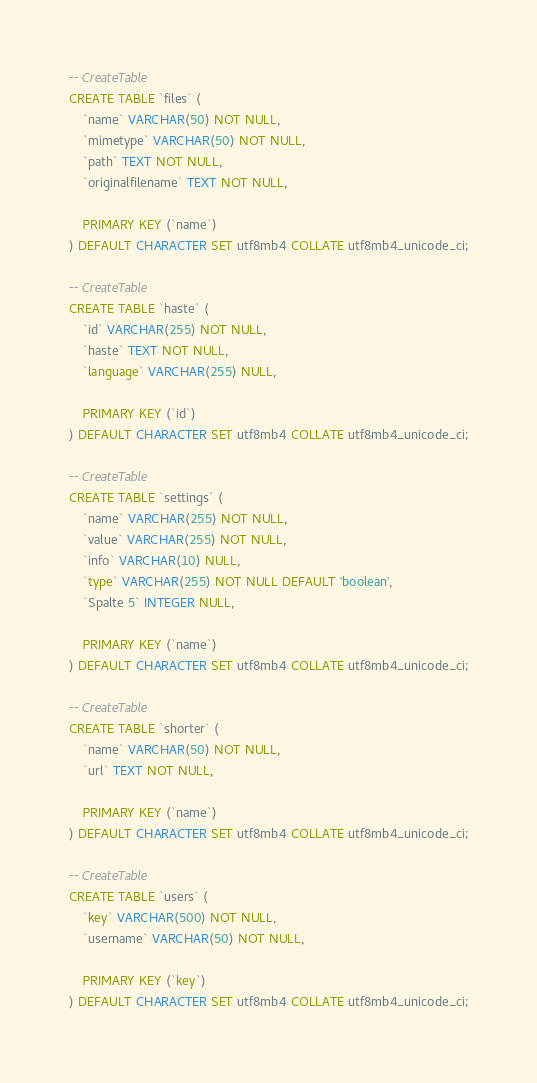<code> <loc_0><loc_0><loc_500><loc_500><_SQL_>-- CreateTable
CREATE TABLE `files` (
    `name` VARCHAR(50) NOT NULL,
    `mimetype` VARCHAR(50) NOT NULL,
    `path` TEXT NOT NULL,
    `originalfilename` TEXT NOT NULL,

    PRIMARY KEY (`name`)
) DEFAULT CHARACTER SET utf8mb4 COLLATE utf8mb4_unicode_ci;

-- CreateTable
CREATE TABLE `haste` (
    `id` VARCHAR(255) NOT NULL,
    `haste` TEXT NOT NULL,
    `language` VARCHAR(255) NULL,

    PRIMARY KEY (`id`)
) DEFAULT CHARACTER SET utf8mb4 COLLATE utf8mb4_unicode_ci;

-- CreateTable
CREATE TABLE `settings` (
    `name` VARCHAR(255) NOT NULL,
    `value` VARCHAR(255) NOT NULL,
    `info` VARCHAR(10) NULL,
    `type` VARCHAR(255) NOT NULL DEFAULT 'boolean',
    `Spalte 5` INTEGER NULL,

    PRIMARY KEY (`name`)
) DEFAULT CHARACTER SET utf8mb4 COLLATE utf8mb4_unicode_ci;

-- CreateTable
CREATE TABLE `shorter` (
    `name` VARCHAR(50) NOT NULL,
    `url` TEXT NOT NULL,

    PRIMARY KEY (`name`)
) DEFAULT CHARACTER SET utf8mb4 COLLATE utf8mb4_unicode_ci;

-- CreateTable
CREATE TABLE `users` (
    `key` VARCHAR(500) NOT NULL,
    `username` VARCHAR(50) NOT NULL,

    PRIMARY KEY (`key`)
) DEFAULT CHARACTER SET utf8mb4 COLLATE utf8mb4_unicode_ci;
</code> 